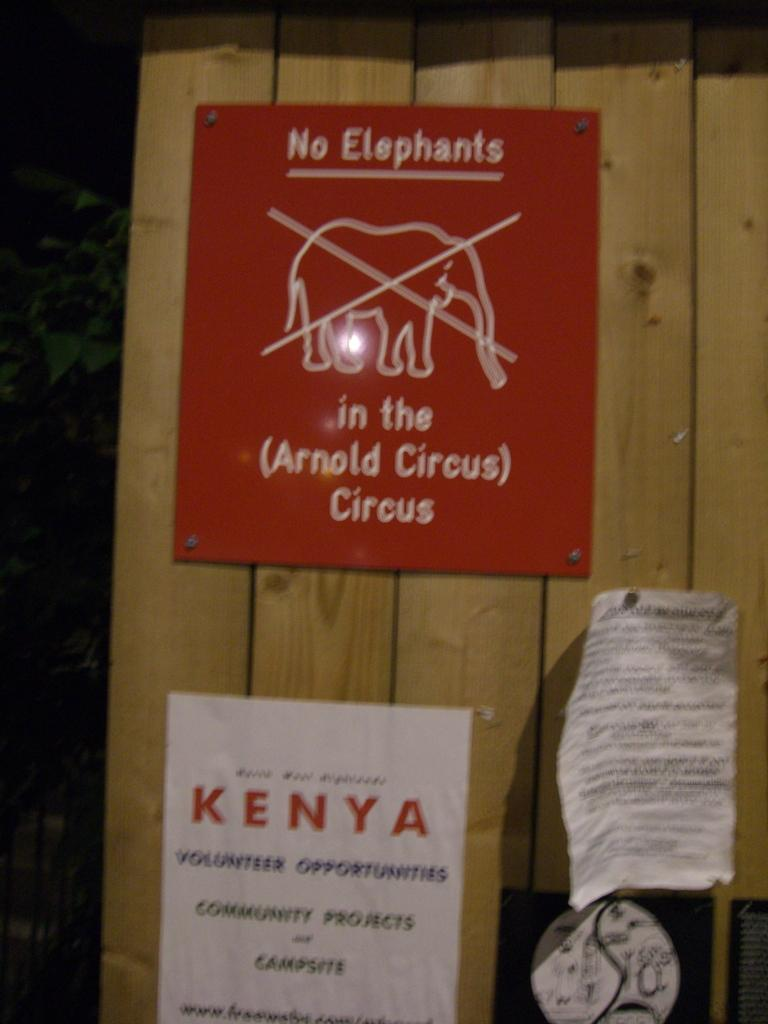What can be seen on the walls in the image? There are posters in the image. What is written or displayed on the posters? The posters have text on them. What type of surface are the posters attached to? The posters are on a wooden surface. What type of music can be heard playing in the background of the image? There is no music or audio present in the image, as it is a still image. 